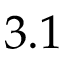Convert formula to latex. <formula><loc_0><loc_0><loc_500><loc_500>3 . 1</formula> 